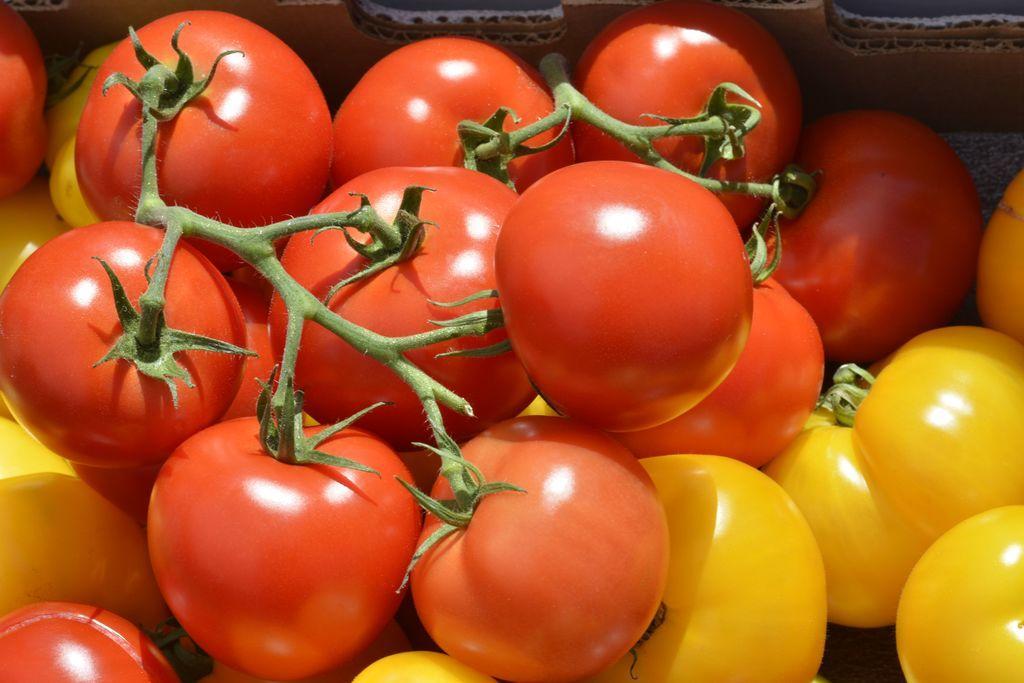Describe this image in one or two sentences. In this picture I can see number of tomatoes and I see that they're of red and yellow color and I can see the green color stems on few tomatoes. In the background I can see the brown color thing. 